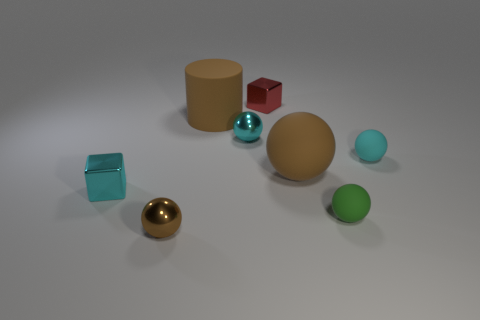Subtract all gray blocks. How many cyan balls are left? 2 Subtract all brown rubber balls. How many balls are left? 4 Subtract 2 spheres. How many spheres are left? 3 Subtract all cyan spheres. How many spheres are left? 3 Add 2 cyan matte things. How many objects exist? 10 Subtract all gray balls. Subtract all gray cubes. How many balls are left? 5 Subtract all cylinders. How many objects are left? 7 Subtract 0 cyan cylinders. How many objects are left? 8 Subtract all tiny cyan shiny objects. Subtract all small cyan things. How many objects are left? 3 Add 8 brown metal balls. How many brown metal balls are left? 9 